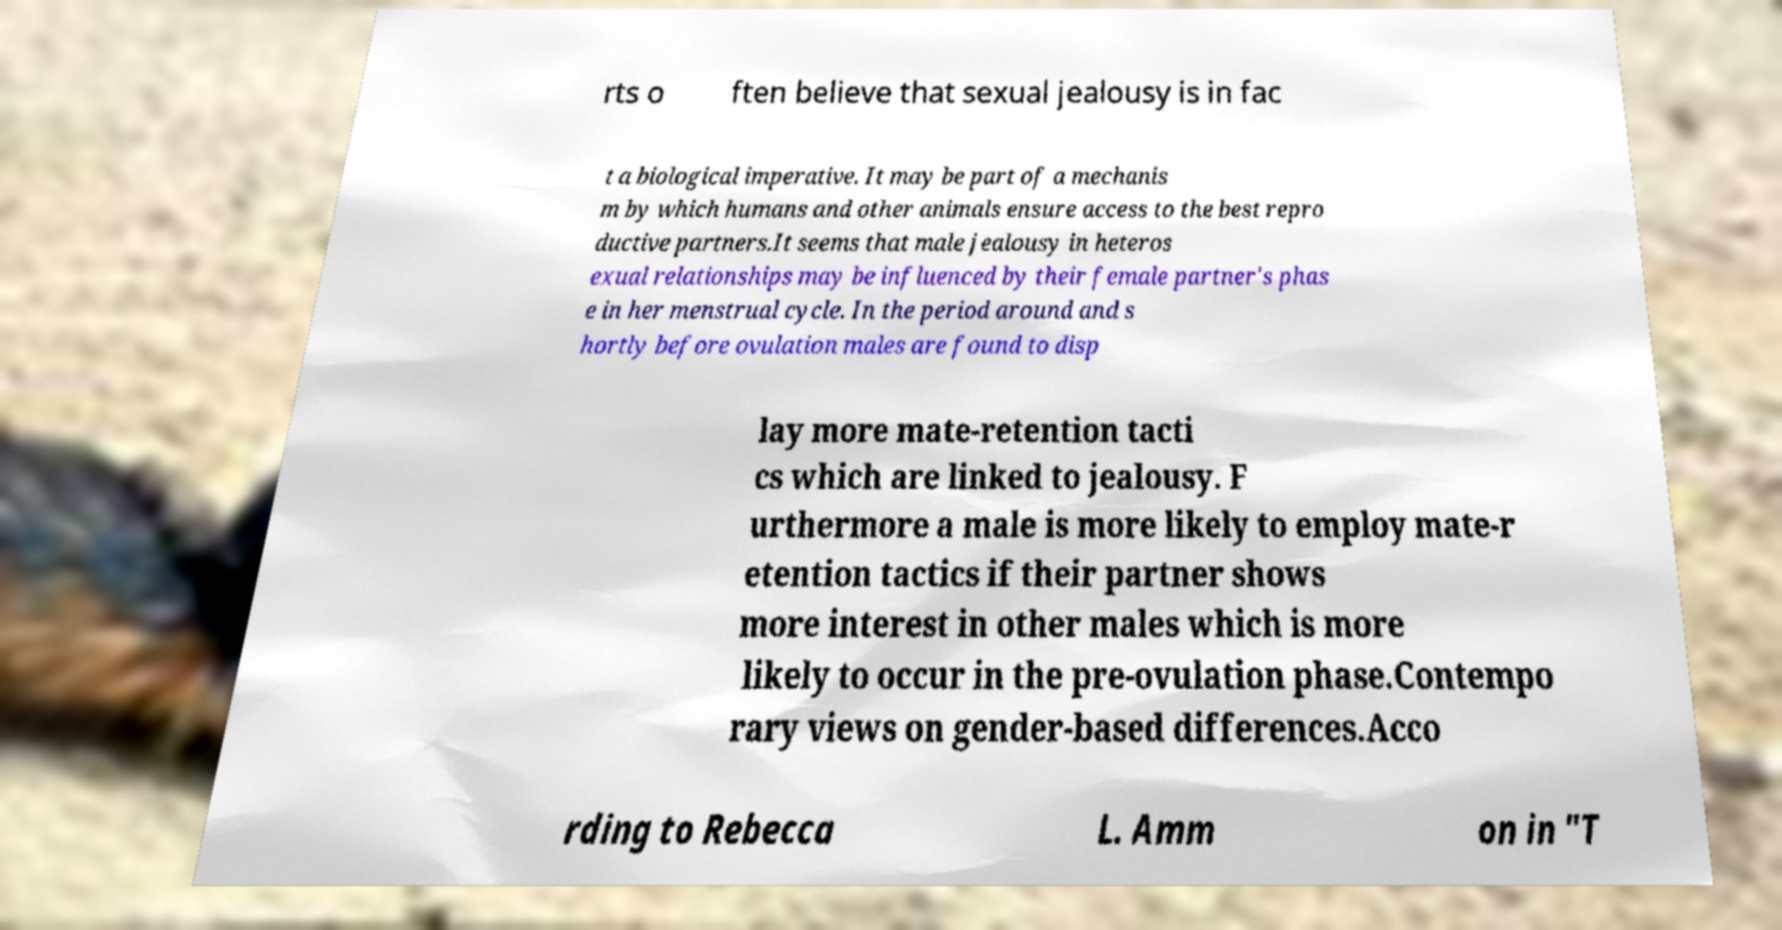There's text embedded in this image that I need extracted. Can you transcribe it verbatim? rts o ften believe that sexual jealousy is in fac t a biological imperative. It may be part of a mechanis m by which humans and other animals ensure access to the best repro ductive partners.It seems that male jealousy in heteros exual relationships may be influenced by their female partner's phas e in her menstrual cycle. In the period around and s hortly before ovulation males are found to disp lay more mate-retention tacti cs which are linked to jealousy. F urthermore a male is more likely to employ mate-r etention tactics if their partner shows more interest in other males which is more likely to occur in the pre-ovulation phase.Contempo rary views on gender-based differences.Acco rding to Rebecca L. Amm on in "T 